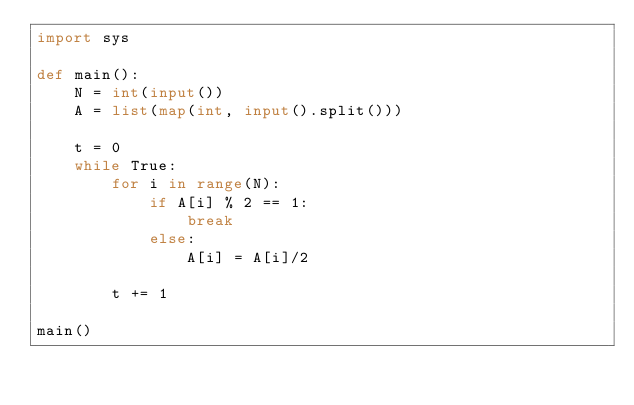Convert code to text. <code><loc_0><loc_0><loc_500><loc_500><_Python_>import sys

def main():
    N = int(input())
    A = list(map(int, input().split()))

    t = 0
    while True:
        for i in range(N):
            if A[i] % 2 == 1:
                break
            else:
                A[i] = A[i]/2
                
        t += 1

main()</code> 